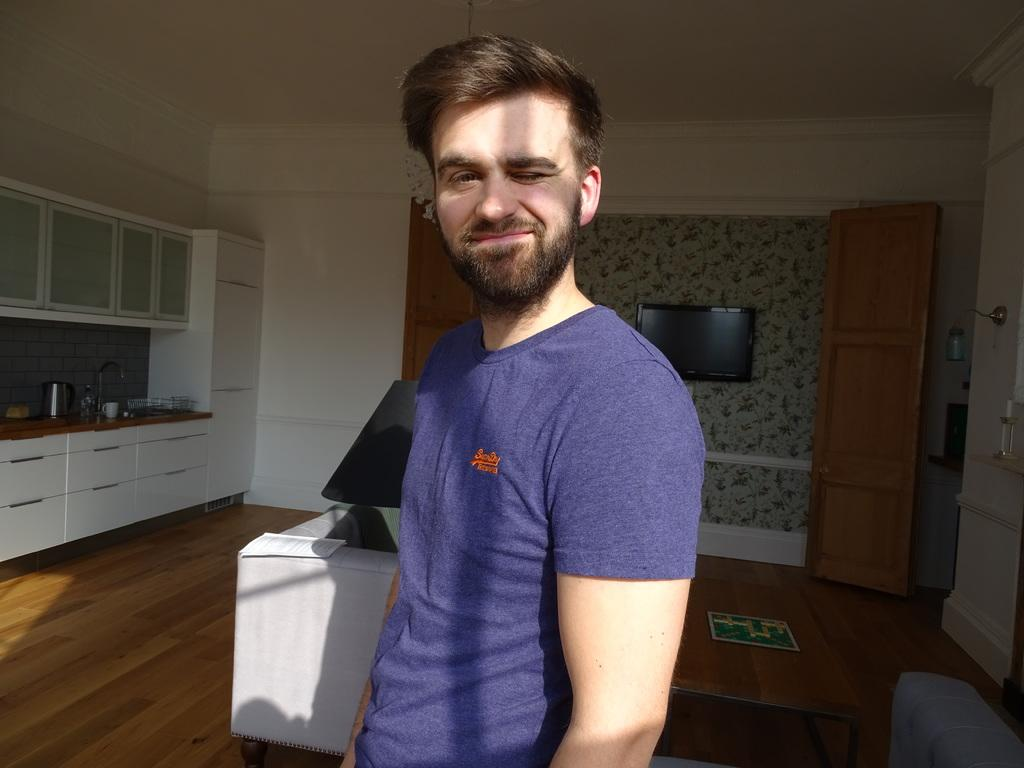Who is present in the image? There is a man in the image. What type of surface is visible in the image? The image shows a floor. What type of furniture can be seen in the image? There is a sofa, a table, and cupboards in the image. What appliance is present in the image? There is a television in the image. What type of fixture is present in the image? There is a tap in the image. What type of containers are present in the image? There is a cup and a jar in the image. What architectural features can be seen in the image? There are doors and a wall in the image. What type of leaf can be seen blowing in the wind in the image? There is no leaf present in the image; it is an indoor scene with no visible foliage. 